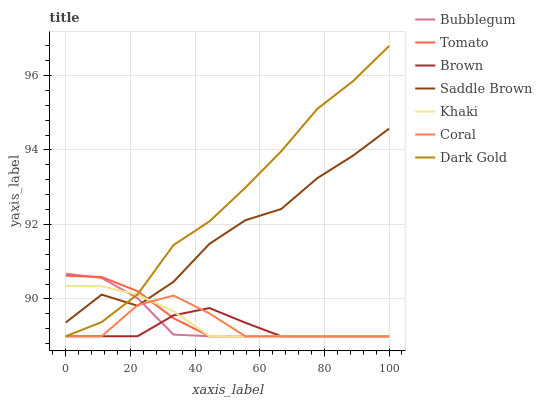Does Brown have the minimum area under the curve?
Answer yes or no. Yes. Does Dark Gold have the maximum area under the curve?
Answer yes or no. Yes. Does Khaki have the minimum area under the curve?
Answer yes or no. No. Does Khaki have the maximum area under the curve?
Answer yes or no. No. Is Khaki the smoothest?
Answer yes or no. Yes. Is Saddle Brown the roughest?
Answer yes or no. Yes. Is Brown the smoothest?
Answer yes or no. No. Is Brown the roughest?
Answer yes or no. No. Does Tomato have the lowest value?
Answer yes or no. Yes. Does Saddle Brown have the lowest value?
Answer yes or no. No. Does Dark Gold have the highest value?
Answer yes or no. Yes. Does Khaki have the highest value?
Answer yes or no. No. Is Brown less than Saddle Brown?
Answer yes or no. Yes. Is Saddle Brown greater than Brown?
Answer yes or no. Yes. Does Tomato intersect Brown?
Answer yes or no. Yes. Is Tomato less than Brown?
Answer yes or no. No. Is Tomato greater than Brown?
Answer yes or no. No. Does Brown intersect Saddle Brown?
Answer yes or no. No. 